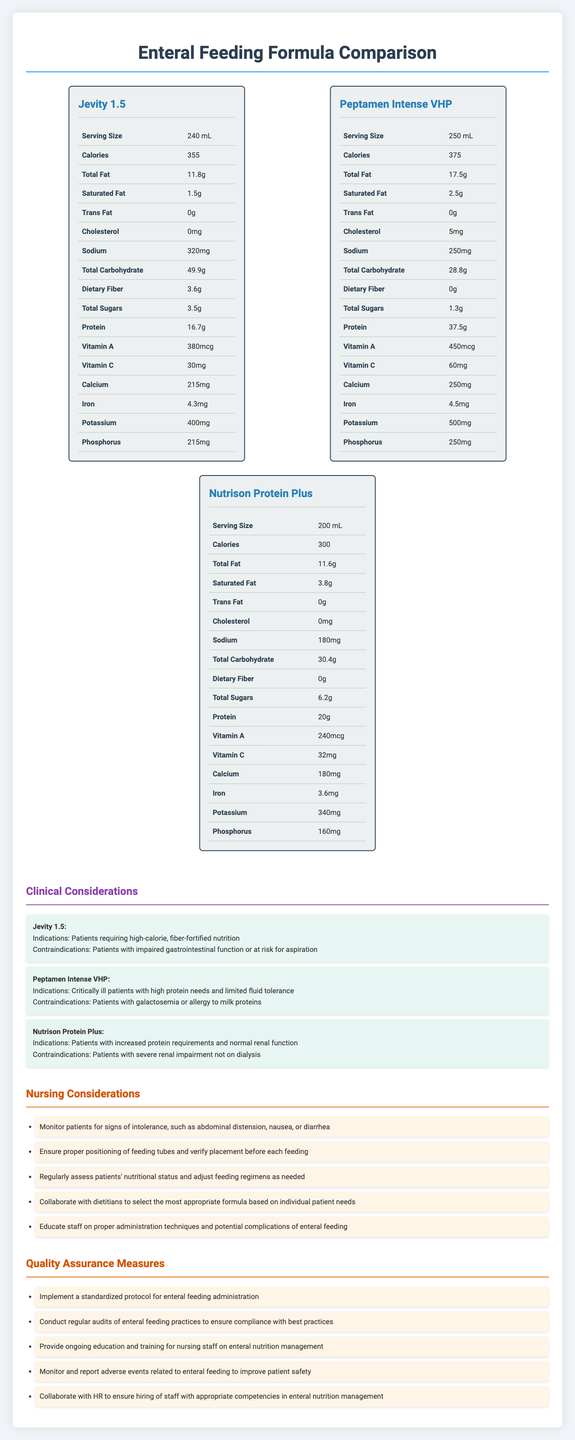what is the serving size for Jevity 1.5? The document lists the serving size for Jevity 1.5 as 240 mL under the nutrition label.
Answer: 240 mL how many calories does Peptamen Intense VHP contain? The calories for Peptamen Intense VHP are listed as 375 on the document.
Answer: 375 what is the total fat content in Nutrison Protein Plus? The total fat content for Nutrison Protein Plus is given as 11.6 grams in the nutrition label section.
Answer: 11.6g which formula has the highest protein content? A. Jevity 1.5 B. Peptamen Intense VHP C. Nutrison Protein Plus Peptamen Intense VHP contains 37.5g of protein, which is higher than Jevity 1.5's 16.7g and Nutrison Protein Plus's 20g.
Answer: B what are the contraindications for Jevity 1.5? The contraindications for Jevity 1.5 are listed explicitly in the clinical considerations section of the document.
Answer: Patients with impaired gastrointestinal function or at risk for aspiration which formula has the highest sodium content? Jevity 1.5 has 320mg of sodium, which is higher than Peptamen Intense VHP's 250mg and Nutrison Protein Plus's 180mg.
Answer: Jevity 1.5 what is the potassium content in Peptamen Intense VHP? The potassium content in Peptamen Intense VHP is listed as 500mg in the nutrition facts section.
Answer: 500mg how many formulas in the document have 0 grams of trans fat? All three formulas (Jevity 1.5, Peptamen Intense VHP, Nutrison Protein Plus) have 0 grams of trans fat as listed in their individual nutrition facts.
Answer: Three which formula is contraindicated for patients with severe renal impairment not on dialysis? A. Jevity 1.5 B. Peptamen Intense VHP C. Nutrison Protein Plus Nutrison Protein Plus is contraindicated for patients with severe renal impairment not on dialysis according to the clinical considerations.
Answer: C do all three enteral feeding formulas contain dietary fiber? Only Jevity 1.5 contains dietary fiber (3.6g); the other two formulas have 0 grams of dietary fiber.
Answer: No summarize the document The main idea of the document is to provide comprehensive information on the nutritional content, clinical considerations, and best practices related to the use of different enteral feeding formulas in a critical care setting.
Answer: The document provides a detailed comparison of three enteral feeding formulas—Jevity 1.5, Peptamen Intense VHP, and Nutrison Protein Plus—outlining their nutrition facts, clinical indications, nursing considerations, and quality assurance measures. It serves as a guide for nursing staff in critical care settings to choose the most appropriate formula based on individual patient needs and to implement best practices in enteral feeding administration. what is the cholesterol content of Nutrison Protein Plus? The document clearly lists the cholesterol content of Nutrison Protein Plus as 0mg.
Answer: Cannot be determined 